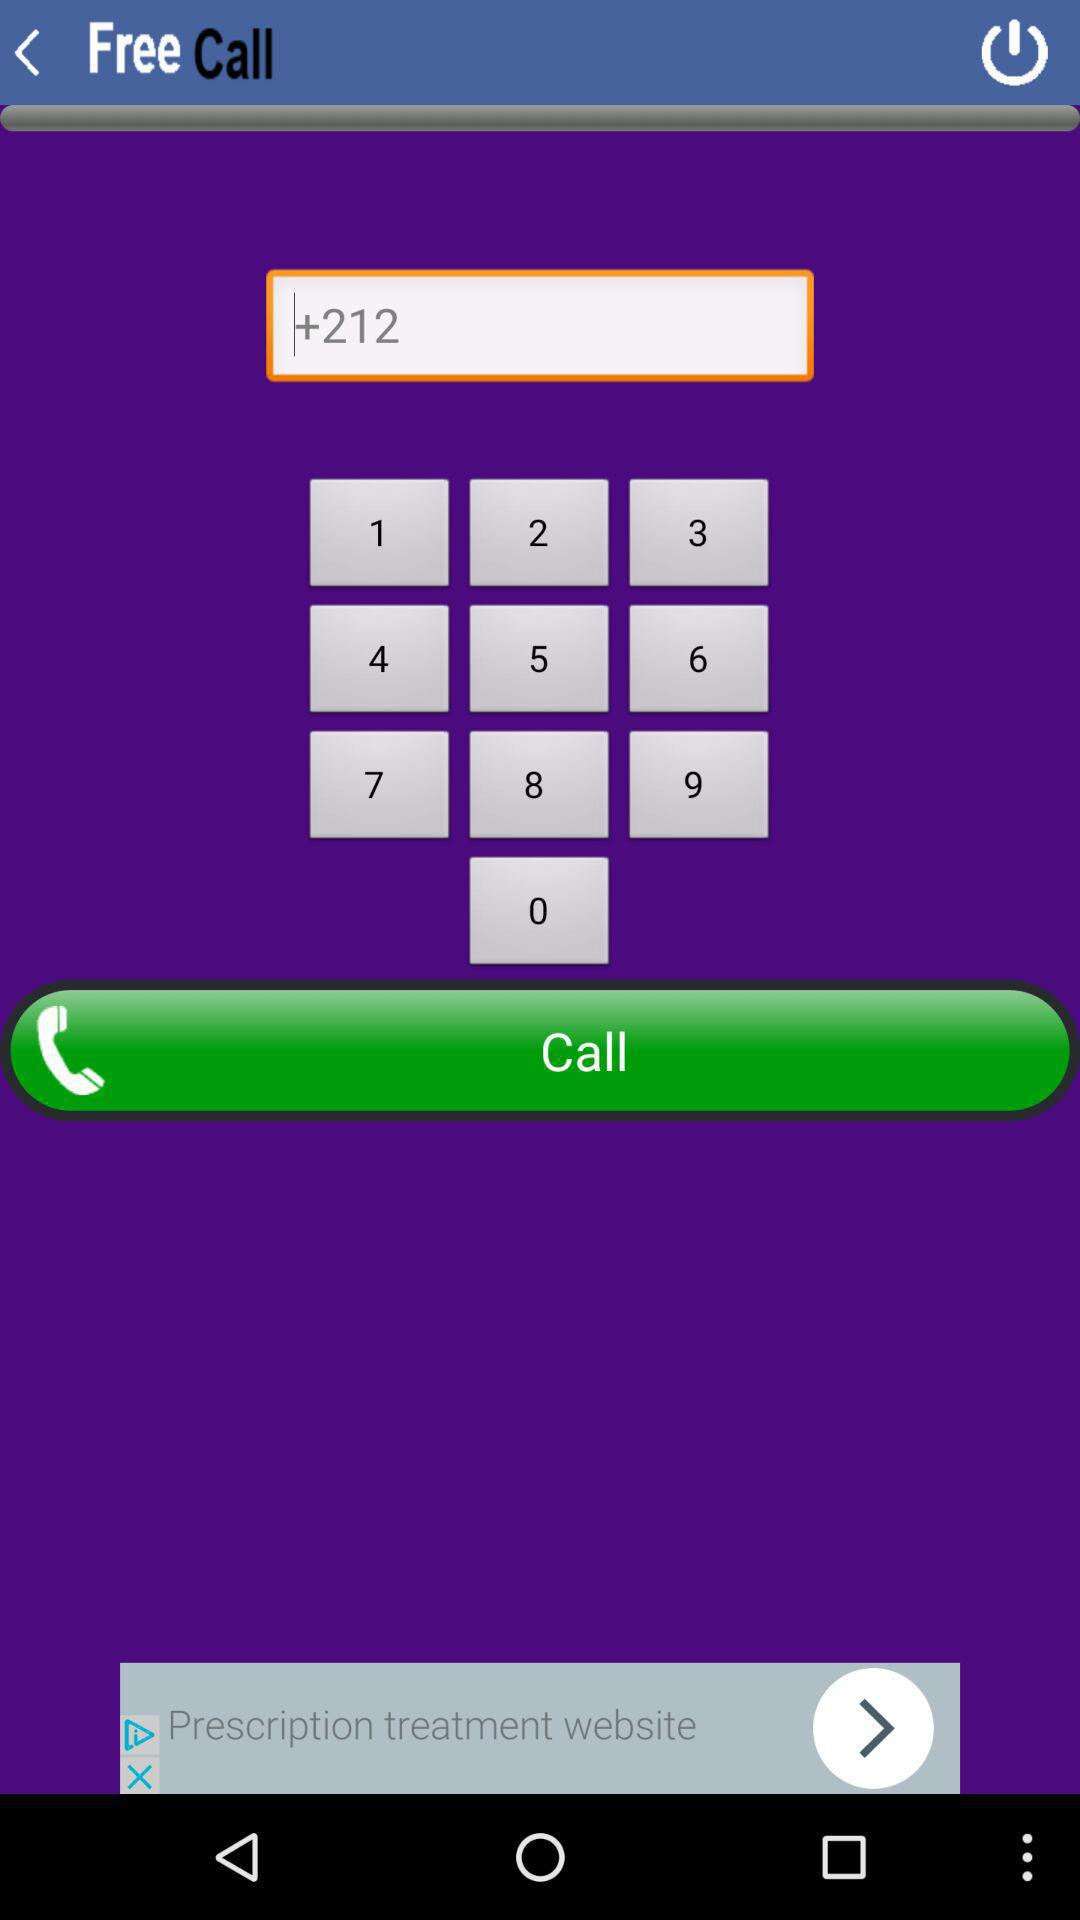When was the last free call placed?
When the provided information is insufficient, respond with <no answer>. <no answer> 